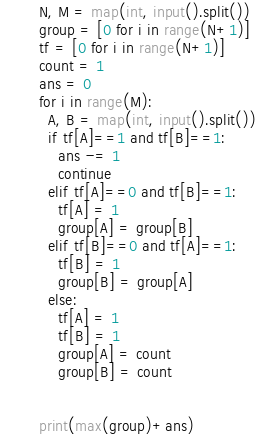<code> <loc_0><loc_0><loc_500><loc_500><_Python_>N, M = map(int, input().split())
group = [0 for i in range(N+1)]
tf = [0 for i in range(N+1)]
count = 1
ans = 0
for i in range(M):
  A, B = map(int, input().split())
  if tf[A]==1 and tf[B]==1:
    ans -= 1
    continue
  elif tf[A]==0 and tf[B]==1:
    tf[A] = 1
    group[A] = group[B]
  elif tf[B]==0 and tf[A]==1:
    tf[B] = 1
    group[B] = group[A]
  else:
    tf[A] = 1
    tf[B] = 1
    group[A] = count
    group[B] = count

   
print(max(group)+ans)</code> 